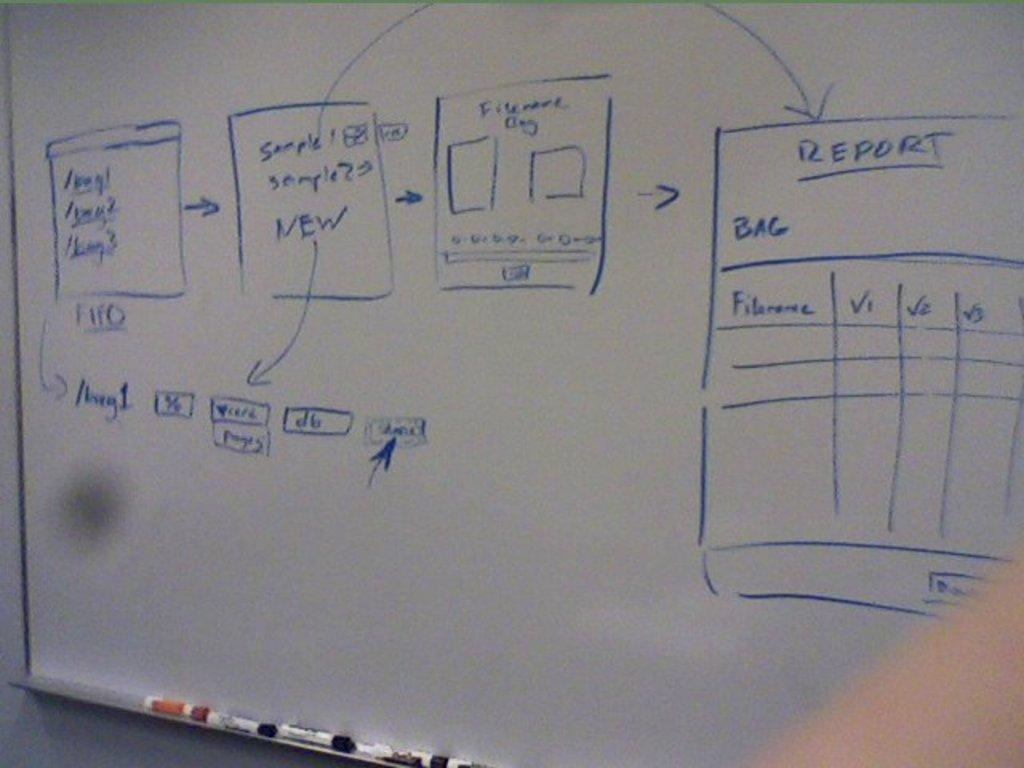<image>
Relay a brief, clear account of the picture shown. A whiteboard has various charts on it including one related to a bag report. 